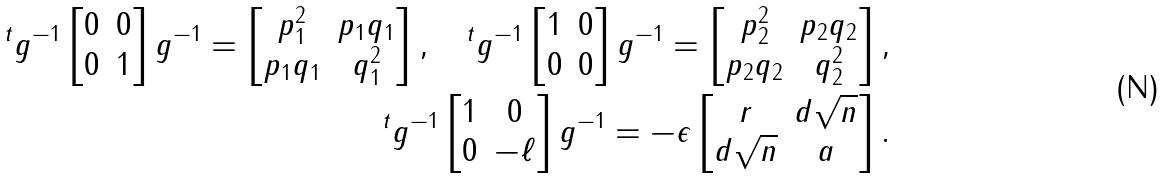Convert formula to latex. <formula><loc_0><loc_0><loc_500><loc_500>^ { t } g ^ { - 1 } \begin{bmatrix} 0 & 0 \\ 0 & 1 \end{bmatrix} g ^ { - 1 } = \begin{bmatrix} p _ { 1 } ^ { 2 } & p _ { 1 } q _ { 1 } \\ p _ { 1 } q _ { 1 } & q _ { 1 } ^ { 2 } \end{bmatrix} , \quad ^ { t } g ^ { - 1 } \begin{bmatrix} 1 & 0 \\ 0 & 0 \end{bmatrix} g ^ { - 1 } = \begin{bmatrix} p _ { 2 } ^ { 2 } & p _ { 2 } q _ { 2 } \\ p _ { 2 } q _ { 2 } & q _ { 2 } ^ { 2 } \end{bmatrix} , \\ ^ { t } g ^ { - 1 } \begin{bmatrix} 1 & 0 \\ 0 & - \ell \end{bmatrix} g ^ { - 1 } = - \epsilon \begin{bmatrix} r & d \sqrt { n } \\ d \sqrt { n } & a \end{bmatrix} .</formula> 